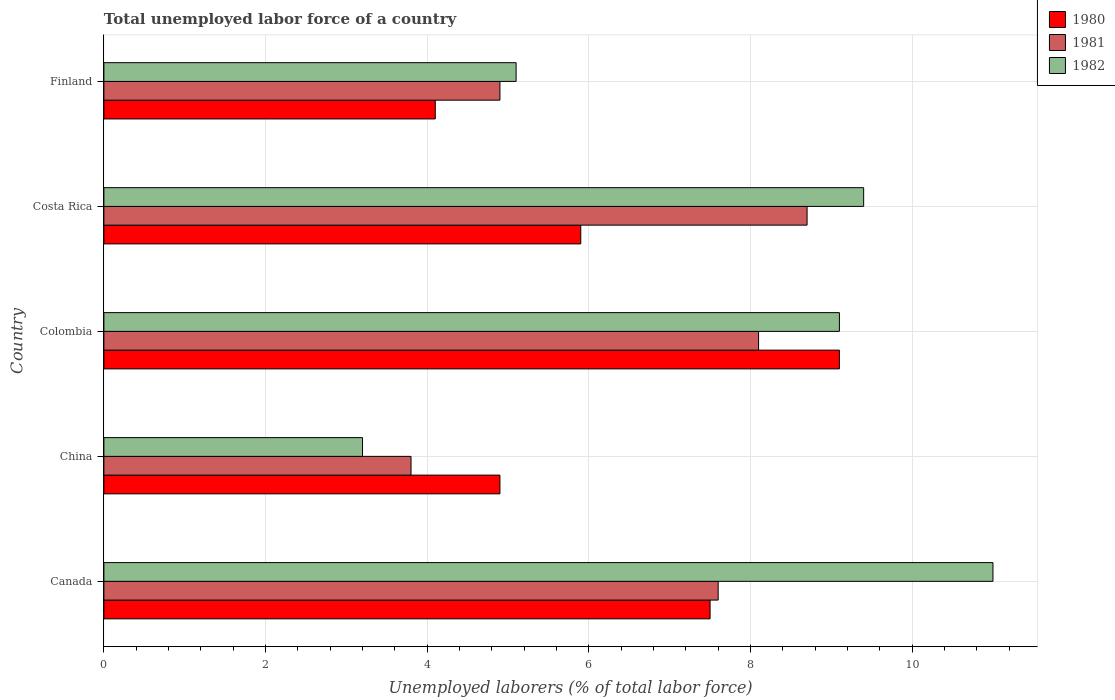How many bars are there on the 1st tick from the bottom?
Offer a very short reply. 3. What is the total unemployed labor force in 1982 in Colombia?
Your answer should be compact. 9.1. Across all countries, what is the maximum total unemployed labor force in 1981?
Your answer should be very brief. 8.7. Across all countries, what is the minimum total unemployed labor force in 1980?
Your answer should be very brief. 4.1. In which country was the total unemployed labor force in 1982 minimum?
Offer a terse response. China. What is the total total unemployed labor force in 1982 in the graph?
Your answer should be very brief. 37.8. What is the difference between the total unemployed labor force in 1982 in China and that in Costa Rica?
Ensure brevity in your answer.  -6.2. What is the difference between the total unemployed labor force in 1980 in Costa Rica and the total unemployed labor force in 1982 in Finland?
Offer a very short reply. 0.8. What is the average total unemployed labor force in 1981 per country?
Offer a very short reply. 6.62. What is the difference between the total unemployed labor force in 1981 and total unemployed labor force in 1980 in Costa Rica?
Your answer should be very brief. 2.8. What is the ratio of the total unemployed labor force in 1981 in China to that in Finland?
Your answer should be very brief. 0.78. Is the difference between the total unemployed labor force in 1981 in China and Finland greater than the difference between the total unemployed labor force in 1980 in China and Finland?
Give a very brief answer. No. What is the difference between the highest and the second highest total unemployed labor force in 1982?
Provide a succinct answer. 1.6. What is the difference between the highest and the lowest total unemployed labor force in 1982?
Offer a terse response. 7.8. What does the 1st bar from the top in Finland represents?
Make the answer very short. 1982. What does the 1st bar from the bottom in Colombia represents?
Your answer should be very brief. 1980. Are all the bars in the graph horizontal?
Ensure brevity in your answer.  Yes. Where does the legend appear in the graph?
Give a very brief answer. Top right. How are the legend labels stacked?
Your response must be concise. Vertical. What is the title of the graph?
Your answer should be compact. Total unemployed labor force of a country. What is the label or title of the X-axis?
Offer a terse response. Unemployed laborers (% of total labor force). What is the label or title of the Y-axis?
Ensure brevity in your answer.  Country. What is the Unemployed laborers (% of total labor force) in 1981 in Canada?
Your response must be concise. 7.6. What is the Unemployed laborers (% of total labor force) in 1982 in Canada?
Keep it short and to the point. 11. What is the Unemployed laborers (% of total labor force) in 1980 in China?
Offer a terse response. 4.9. What is the Unemployed laborers (% of total labor force) of 1981 in China?
Provide a succinct answer. 3.8. What is the Unemployed laborers (% of total labor force) of 1982 in China?
Make the answer very short. 3.2. What is the Unemployed laborers (% of total labor force) in 1980 in Colombia?
Give a very brief answer. 9.1. What is the Unemployed laborers (% of total labor force) in 1981 in Colombia?
Keep it short and to the point. 8.1. What is the Unemployed laborers (% of total labor force) in 1982 in Colombia?
Keep it short and to the point. 9.1. What is the Unemployed laborers (% of total labor force) of 1980 in Costa Rica?
Keep it short and to the point. 5.9. What is the Unemployed laborers (% of total labor force) in 1981 in Costa Rica?
Your answer should be very brief. 8.7. What is the Unemployed laborers (% of total labor force) in 1982 in Costa Rica?
Provide a short and direct response. 9.4. What is the Unemployed laborers (% of total labor force) of 1980 in Finland?
Provide a succinct answer. 4.1. What is the Unemployed laborers (% of total labor force) in 1981 in Finland?
Offer a very short reply. 4.9. What is the Unemployed laborers (% of total labor force) in 1982 in Finland?
Keep it short and to the point. 5.1. Across all countries, what is the maximum Unemployed laborers (% of total labor force) in 1980?
Keep it short and to the point. 9.1. Across all countries, what is the maximum Unemployed laborers (% of total labor force) in 1981?
Make the answer very short. 8.7. Across all countries, what is the maximum Unemployed laborers (% of total labor force) in 1982?
Give a very brief answer. 11. Across all countries, what is the minimum Unemployed laborers (% of total labor force) of 1980?
Your response must be concise. 4.1. Across all countries, what is the minimum Unemployed laborers (% of total labor force) in 1981?
Provide a short and direct response. 3.8. Across all countries, what is the minimum Unemployed laborers (% of total labor force) of 1982?
Provide a succinct answer. 3.2. What is the total Unemployed laborers (% of total labor force) of 1980 in the graph?
Your answer should be compact. 31.5. What is the total Unemployed laborers (% of total labor force) in 1981 in the graph?
Provide a short and direct response. 33.1. What is the total Unemployed laborers (% of total labor force) of 1982 in the graph?
Provide a short and direct response. 37.8. What is the difference between the Unemployed laborers (% of total labor force) of 1981 in Canada and that in China?
Your response must be concise. 3.8. What is the difference between the Unemployed laborers (% of total labor force) of 1982 in Canada and that in China?
Your response must be concise. 7.8. What is the difference between the Unemployed laborers (% of total labor force) in 1980 in Canada and that in Colombia?
Make the answer very short. -1.6. What is the difference between the Unemployed laborers (% of total labor force) in 1982 in Canada and that in Colombia?
Your answer should be very brief. 1.9. What is the difference between the Unemployed laborers (% of total labor force) of 1980 in Canada and that in Costa Rica?
Provide a succinct answer. 1.6. What is the difference between the Unemployed laborers (% of total labor force) in 1982 in Canada and that in Costa Rica?
Offer a very short reply. 1.6. What is the difference between the Unemployed laborers (% of total labor force) in 1981 in Canada and that in Finland?
Provide a short and direct response. 2.7. What is the difference between the Unemployed laborers (% of total labor force) in 1982 in Canada and that in Finland?
Give a very brief answer. 5.9. What is the difference between the Unemployed laborers (% of total labor force) in 1980 in China and that in Colombia?
Offer a terse response. -4.2. What is the difference between the Unemployed laborers (% of total labor force) in 1982 in China and that in Colombia?
Your answer should be compact. -5.9. What is the difference between the Unemployed laborers (% of total labor force) of 1980 in China and that in Costa Rica?
Provide a short and direct response. -1. What is the difference between the Unemployed laborers (% of total labor force) of 1981 in China and that in Costa Rica?
Give a very brief answer. -4.9. What is the difference between the Unemployed laborers (% of total labor force) in 1980 in China and that in Finland?
Offer a terse response. 0.8. What is the difference between the Unemployed laborers (% of total labor force) in 1981 in China and that in Finland?
Offer a very short reply. -1.1. What is the difference between the Unemployed laborers (% of total labor force) in 1980 in Colombia and that in Costa Rica?
Keep it short and to the point. 3.2. What is the difference between the Unemployed laborers (% of total labor force) in 1980 in Colombia and that in Finland?
Your response must be concise. 5. What is the difference between the Unemployed laborers (% of total labor force) of 1980 in Costa Rica and that in Finland?
Keep it short and to the point. 1.8. What is the difference between the Unemployed laborers (% of total labor force) of 1981 in Costa Rica and that in Finland?
Your answer should be very brief. 3.8. What is the difference between the Unemployed laborers (% of total labor force) in 1982 in Costa Rica and that in Finland?
Ensure brevity in your answer.  4.3. What is the difference between the Unemployed laborers (% of total labor force) of 1980 in Canada and the Unemployed laborers (% of total labor force) of 1981 in China?
Provide a succinct answer. 3.7. What is the difference between the Unemployed laborers (% of total labor force) of 1981 in Canada and the Unemployed laborers (% of total labor force) of 1982 in China?
Ensure brevity in your answer.  4.4. What is the difference between the Unemployed laborers (% of total labor force) of 1980 in Canada and the Unemployed laborers (% of total labor force) of 1981 in Colombia?
Your answer should be very brief. -0.6. What is the difference between the Unemployed laborers (% of total labor force) of 1981 in Canada and the Unemployed laborers (% of total labor force) of 1982 in Costa Rica?
Your answer should be very brief. -1.8. What is the difference between the Unemployed laborers (% of total labor force) in 1980 in Canada and the Unemployed laborers (% of total labor force) in 1981 in Finland?
Keep it short and to the point. 2.6. What is the difference between the Unemployed laborers (% of total labor force) in 1980 in Canada and the Unemployed laborers (% of total labor force) in 1982 in Finland?
Provide a succinct answer. 2.4. What is the difference between the Unemployed laborers (% of total labor force) in 1981 in Canada and the Unemployed laborers (% of total labor force) in 1982 in Finland?
Keep it short and to the point. 2.5. What is the difference between the Unemployed laborers (% of total labor force) in 1980 in China and the Unemployed laborers (% of total labor force) in 1982 in Colombia?
Your answer should be compact. -4.2. What is the difference between the Unemployed laborers (% of total labor force) of 1981 in China and the Unemployed laborers (% of total labor force) of 1982 in Colombia?
Offer a very short reply. -5.3. What is the difference between the Unemployed laborers (% of total labor force) of 1980 in China and the Unemployed laborers (% of total labor force) of 1982 in Costa Rica?
Ensure brevity in your answer.  -4.5. What is the difference between the Unemployed laborers (% of total labor force) of 1981 in China and the Unemployed laborers (% of total labor force) of 1982 in Costa Rica?
Make the answer very short. -5.6. What is the difference between the Unemployed laborers (% of total labor force) of 1980 in Colombia and the Unemployed laborers (% of total labor force) of 1981 in Costa Rica?
Your answer should be compact. 0.4. What is the difference between the Unemployed laborers (% of total labor force) of 1981 in Colombia and the Unemployed laborers (% of total labor force) of 1982 in Costa Rica?
Your answer should be compact. -1.3. What is the difference between the Unemployed laborers (% of total labor force) of 1980 in Costa Rica and the Unemployed laborers (% of total labor force) of 1981 in Finland?
Your answer should be very brief. 1. What is the difference between the Unemployed laborers (% of total labor force) of 1980 in Costa Rica and the Unemployed laborers (% of total labor force) of 1982 in Finland?
Ensure brevity in your answer.  0.8. What is the difference between the Unemployed laborers (% of total labor force) in 1981 in Costa Rica and the Unemployed laborers (% of total labor force) in 1982 in Finland?
Offer a terse response. 3.6. What is the average Unemployed laborers (% of total labor force) in 1981 per country?
Your answer should be very brief. 6.62. What is the average Unemployed laborers (% of total labor force) of 1982 per country?
Your answer should be compact. 7.56. What is the difference between the Unemployed laborers (% of total labor force) in 1980 and Unemployed laborers (% of total labor force) in 1982 in China?
Offer a very short reply. 1.7. What is the difference between the Unemployed laborers (% of total labor force) in 1980 and Unemployed laborers (% of total labor force) in 1981 in Colombia?
Make the answer very short. 1. What is the difference between the Unemployed laborers (% of total labor force) in 1980 and Unemployed laborers (% of total labor force) in 1982 in Colombia?
Ensure brevity in your answer.  0. What is the difference between the Unemployed laborers (% of total labor force) in 1981 and Unemployed laborers (% of total labor force) in 1982 in Colombia?
Give a very brief answer. -1. What is the difference between the Unemployed laborers (% of total labor force) in 1980 and Unemployed laborers (% of total labor force) in 1982 in Costa Rica?
Your answer should be compact. -3.5. What is the difference between the Unemployed laborers (% of total labor force) of 1980 and Unemployed laborers (% of total labor force) of 1982 in Finland?
Provide a short and direct response. -1. What is the ratio of the Unemployed laborers (% of total labor force) in 1980 in Canada to that in China?
Keep it short and to the point. 1.53. What is the ratio of the Unemployed laborers (% of total labor force) of 1981 in Canada to that in China?
Ensure brevity in your answer.  2. What is the ratio of the Unemployed laborers (% of total labor force) of 1982 in Canada to that in China?
Provide a succinct answer. 3.44. What is the ratio of the Unemployed laborers (% of total labor force) in 1980 in Canada to that in Colombia?
Give a very brief answer. 0.82. What is the ratio of the Unemployed laborers (% of total labor force) of 1981 in Canada to that in Colombia?
Provide a succinct answer. 0.94. What is the ratio of the Unemployed laborers (% of total labor force) of 1982 in Canada to that in Colombia?
Your response must be concise. 1.21. What is the ratio of the Unemployed laborers (% of total labor force) in 1980 in Canada to that in Costa Rica?
Give a very brief answer. 1.27. What is the ratio of the Unemployed laborers (% of total labor force) in 1981 in Canada to that in Costa Rica?
Your answer should be very brief. 0.87. What is the ratio of the Unemployed laborers (% of total labor force) of 1982 in Canada to that in Costa Rica?
Give a very brief answer. 1.17. What is the ratio of the Unemployed laborers (% of total labor force) of 1980 in Canada to that in Finland?
Provide a short and direct response. 1.83. What is the ratio of the Unemployed laborers (% of total labor force) in 1981 in Canada to that in Finland?
Offer a terse response. 1.55. What is the ratio of the Unemployed laborers (% of total labor force) of 1982 in Canada to that in Finland?
Provide a succinct answer. 2.16. What is the ratio of the Unemployed laborers (% of total labor force) in 1980 in China to that in Colombia?
Your answer should be compact. 0.54. What is the ratio of the Unemployed laborers (% of total labor force) in 1981 in China to that in Colombia?
Your response must be concise. 0.47. What is the ratio of the Unemployed laborers (% of total labor force) of 1982 in China to that in Colombia?
Offer a terse response. 0.35. What is the ratio of the Unemployed laborers (% of total labor force) in 1980 in China to that in Costa Rica?
Provide a succinct answer. 0.83. What is the ratio of the Unemployed laborers (% of total labor force) in 1981 in China to that in Costa Rica?
Your answer should be very brief. 0.44. What is the ratio of the Unemployed laborers (% of total labor force) of 1982 in China to that in Costa Rica?
Make the answer very short. 0.34. What is the ratio of the Unemployed laborers (% of total labor force) of 1980 in China to that in Finland?
Your answer should be very brief. 1.2. What is the ratio of the Unemployed laborers (% of total labor force) of 1981 in China to that in Finland?
Give a very brief answer. 0.78. What is the ratio of the Unemployed laborers (% of total labor force) of 1982 in China to that in Finland?
Your answer should be compact. 0.63. What is the ratio of the Unemployed laborers (% of total labor force) of 1980 in Colombia to that in Costa Rica?
Give a very brief answer. 1.54. What is the ratio of the Unemployed laborers (% of total labor force) in 1982 in Colombia to that in Costa Rica?
Offer a very short reply. 0.97. What is the ratio of the Unemployed laborers (% of total labor force) of 1980 in Colombia to that in Finland?
Provide a short and direct response. 2.22. What is the ratio of the Unemployed laborers (% of total labor force) of 1981 in Colombia to that in Finland?
Ensure brevity in your answer.  1.65. What is the ratio of the Unemployed laborers (% of total labor force) in 1982 in Colombia to that in Finland?
Offer a terse response. 1.78. What is the ratio of the Unemployed laborers (% of total labor force) in 1980 in Costa Rica to that in Finland?
Provide a succinct answer. 1.44. What is the ratio of the Unemployed laborers (% of total labor force) of 1981 in Costa Rica to that in Finland?
Ensure brevity in your answer.  1.78. What is the ratio of the Unemployed laborers (% of total labor force) in 1982 in Costa Rica to that in Finland?
Ensure brevity in your answer.  1.84. What is the difference between the highest and the second highest Unemployed laborers (% of total labor force) in 1980?
Give a very brief answer. 1.6. What is the difference between the highest and the second highest Unemployed laborers (% of total labor force) in 1981?
Your response must be concise. 0.6. What is the difference between the highest and the lowest Unemployed laborers (% of total labor force) of 1980?
Offer a terse response. 5. What is the difference between the highest and the lowest Unemployed laborers (% of total labor force) in 1981?
Provide a short and direct response. 4.9. 